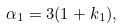Convert formula to latex. <formula><loc_0><loc_0><loc_500><loc_500>\alpha _ { 1 } = 3 ( 1 + k _ { 1 } ) ,</formula> 